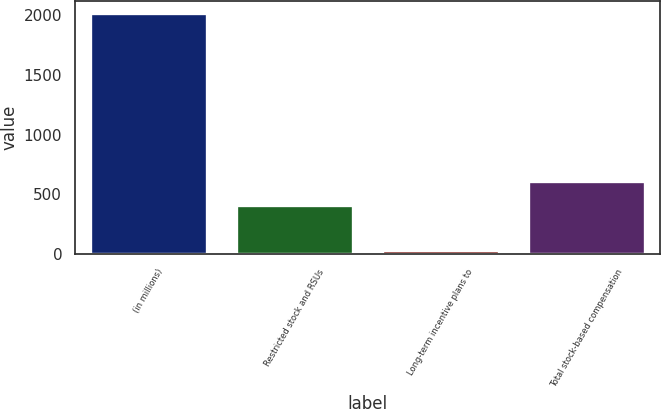Convert chart to OTSL. <chart><loc_0><loc_0><loc_500><loc_500><bar_chart><fcel>(in millions)<fcel>Restricted stock and RSUs<fcel>Long-term incentive plans to<fcel>Total stock-based compensation<nl><fcel>2013<fcel>415<fcel>33<fcel>613<nl></chart> 